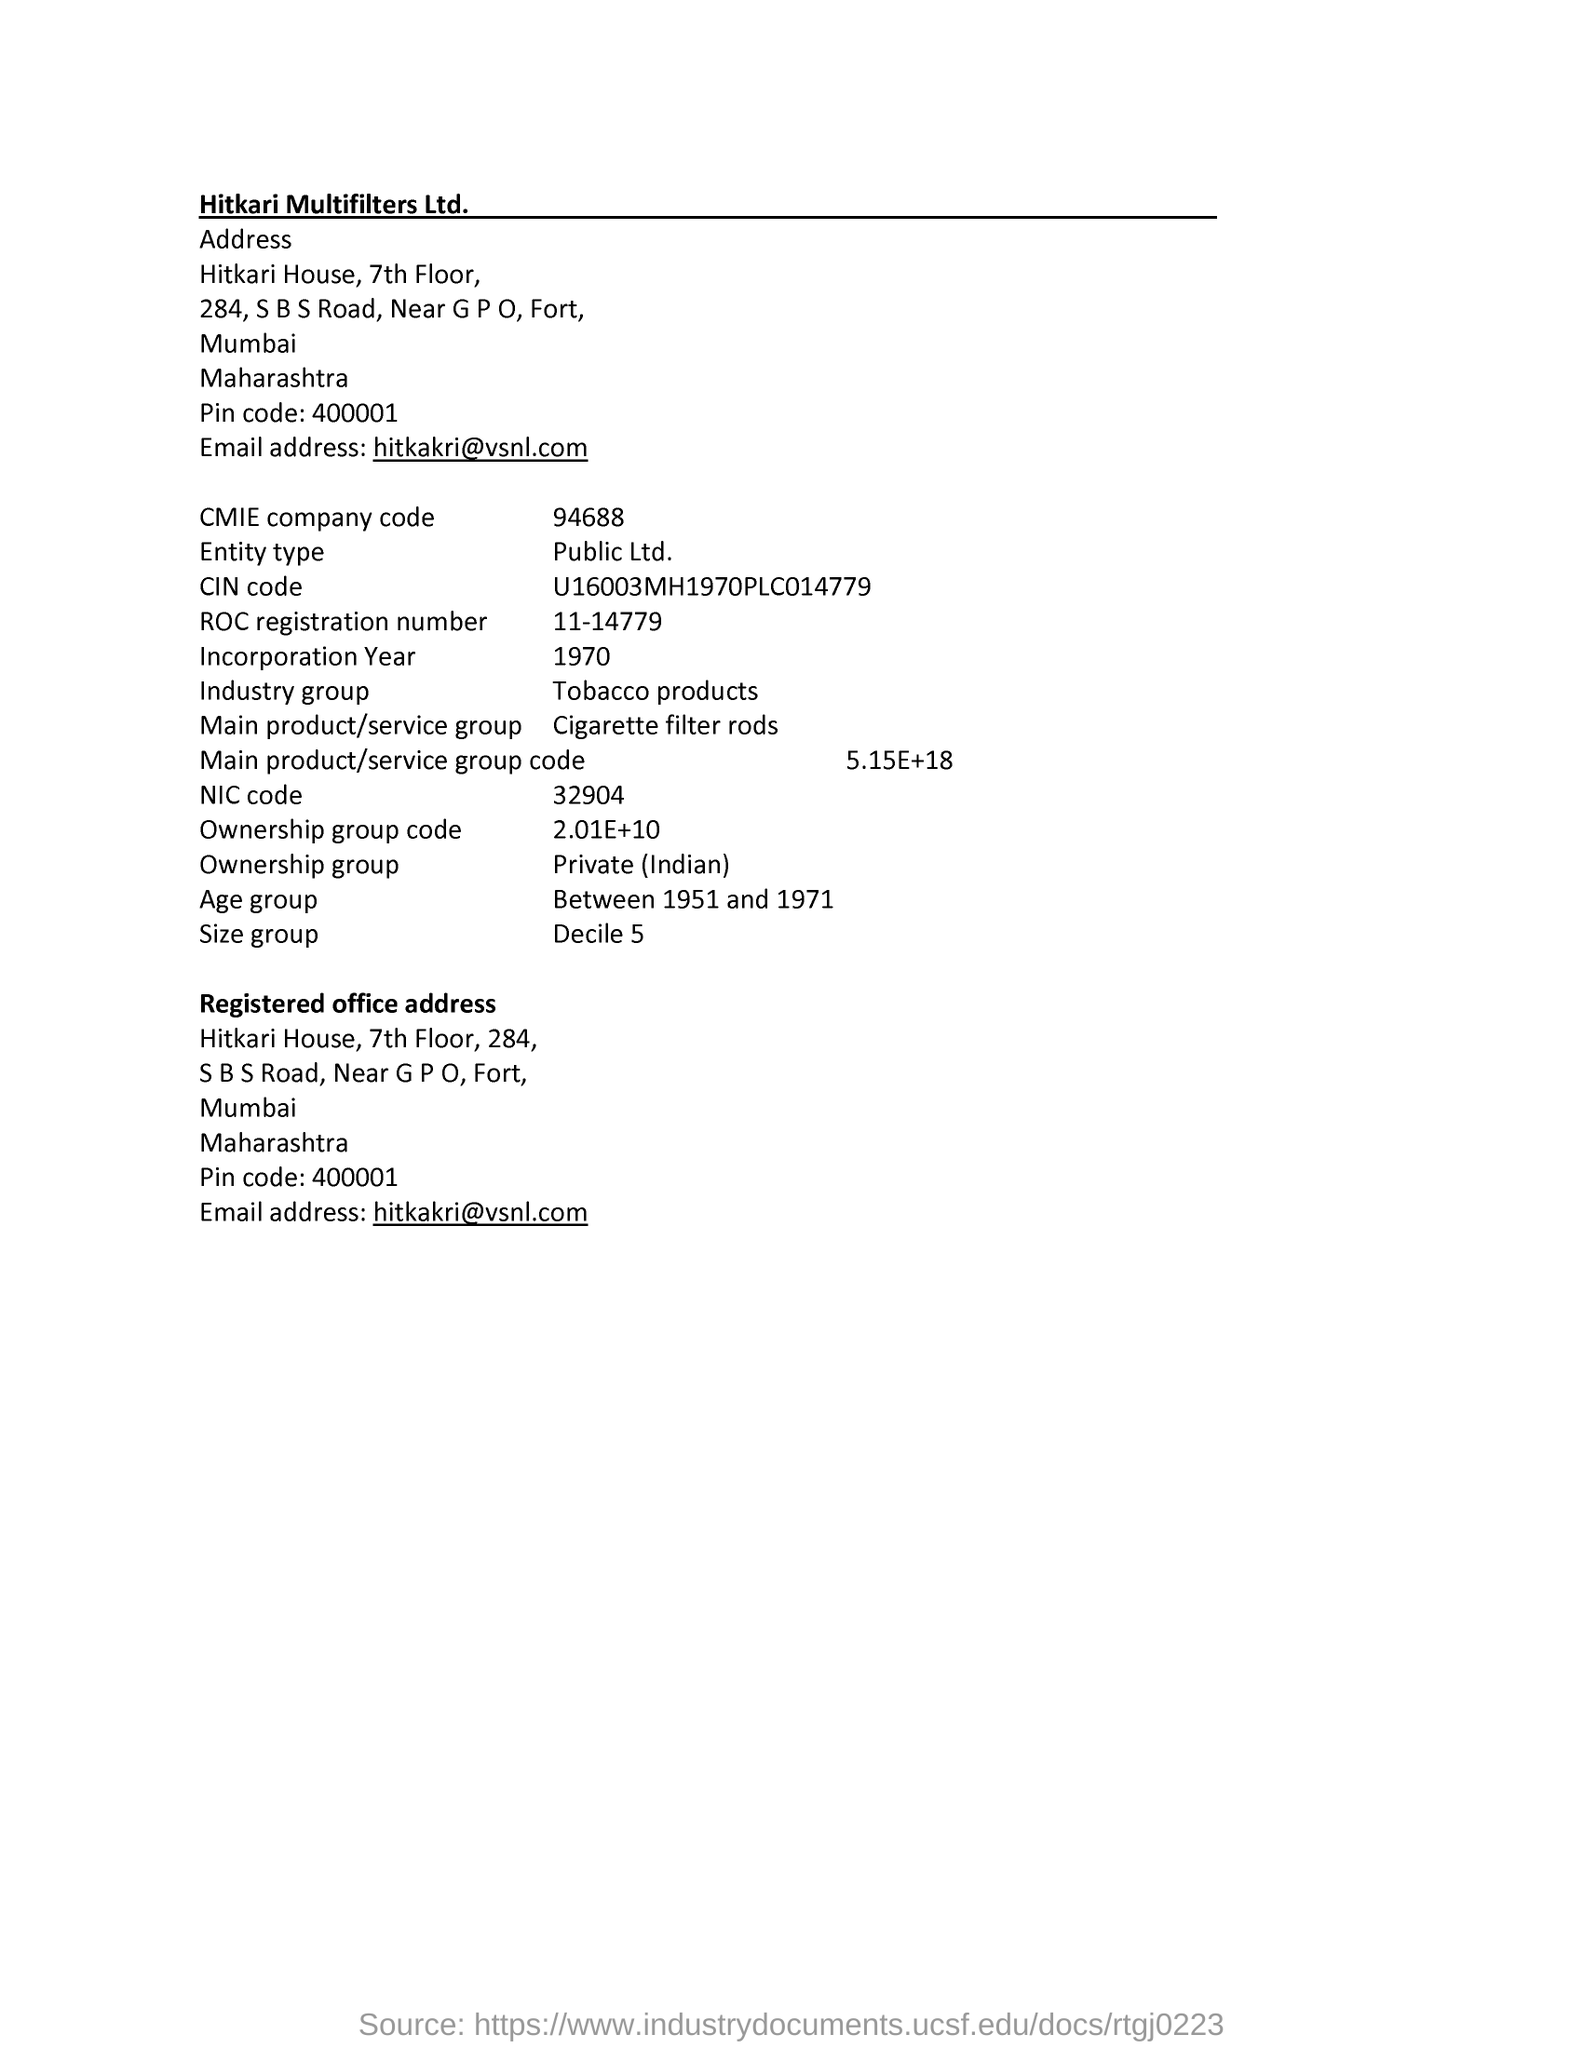Outline some significant characteristics in this image. According to the page, the age group in question is between 1951 and 1971. The CMIE company code is 94688... Hitkari Multifilters Ltd. is the name of the company. The NIC code is 32904. 